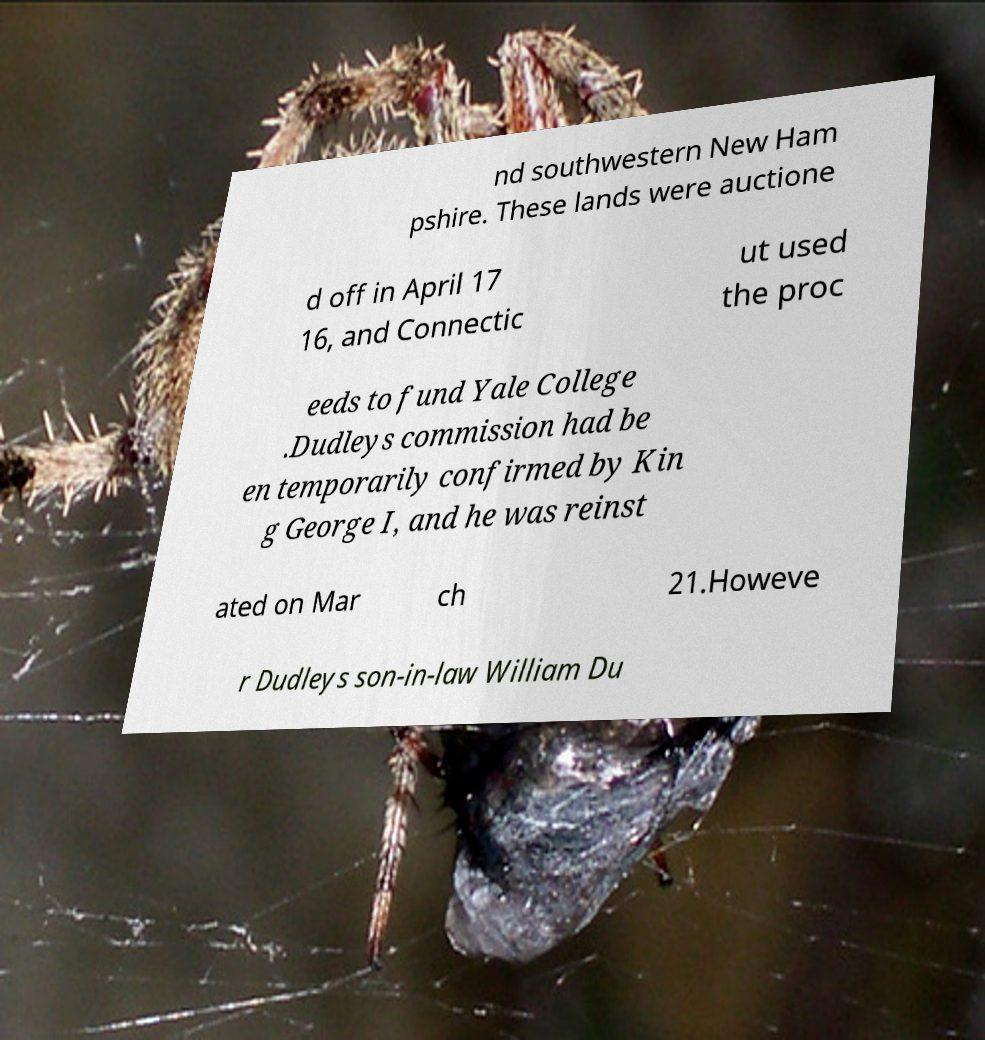Please identify and transcribe the text found in this image. nd southwestern New Ham pshire. These lands were auctione d off in April 17 16, and Connectic ut used the proc eeds to fund Yale College .Dudleys commission had be en temporarily confirmed by Kin g George I, and he was reinst ated on Mar ch 21.Howeve r Dudleys son-in-law William Du 